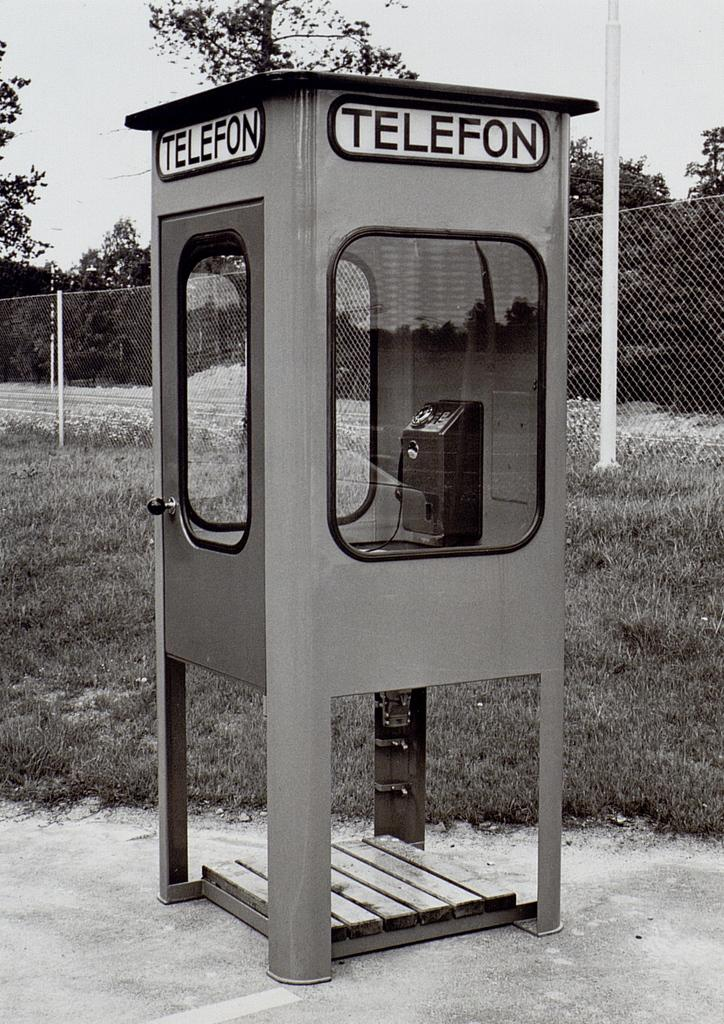Provide a one-sentence caption for the provided image. A black and white phone booth that reads telefon on the top of it. 